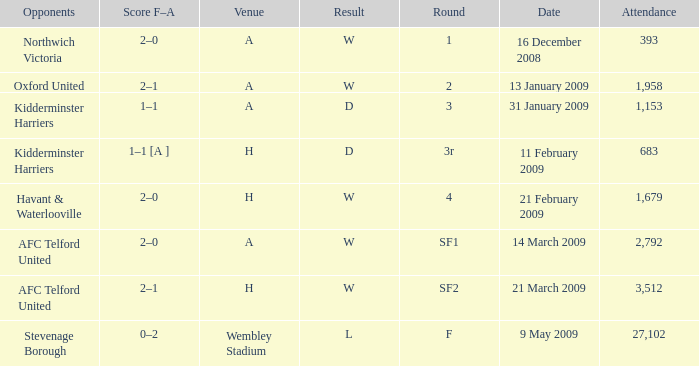What is the round on 21 february 2009? 4.0. 